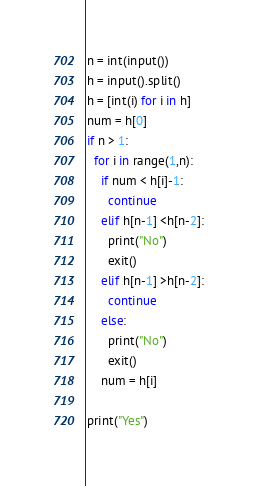Convert code to text. <code><loc_0><loc_0><loc_500><loc_500><_Python_>n = int(input())
h = input().split()
h = [int(i) for i in h]
num = h[0]
if n > 1:
  for i in range(1,n):
    if num < h[i]-1:
      continue
    elif h[n-1] <h[n-2]:
      print("No")
      exit()
    elif h[n-1] >h[n-2]:
      continue
    else:
      print("No")
      exit()
    num = h[i]
  
print("Yes")  </code> 